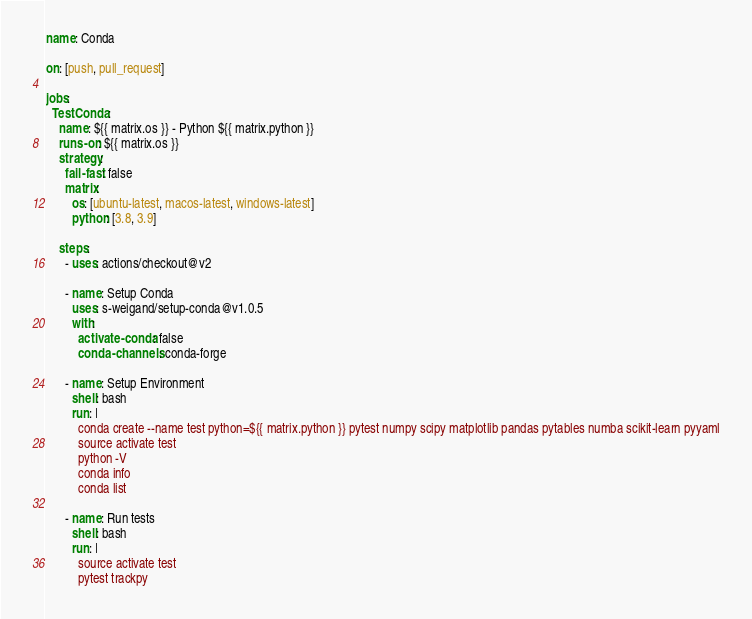Convert code to text. <code><loc_0><loc_0><loc_500><loc_500><_YAML_>name: Conda

on: [push, pull_request]

jobs:
  TestConda:
    name: ${{ matrix.os }} - Python ${{ matrix.python }}
    runs-on: ${{ matrix.os }}
    strategy:
      fail-fast: false
      matrix:
        os: [ubuntu-latest, macos-latest, windows-latest]
        python: [3.8, 3.9]

    steps:
      - uses: actions/checkout@v2

      - name: Setup Conda
        uses: s-weigand/setup-conda@v1.0.5
        with:
          activate-conda: false
          conda-channels: conda-forge

      - name: Setup Environment
        shell: bash
        run: |
          conda create --name test python=${{ matrix.python }} pytest numpy scipy matplotlib pandas pytables numba scikit-learn pyyaml
          source activate test
          python -V
          conda info
          conda list

      - name: Run tests
        shell: bash
        run: |
          source activate test
          pytest trackpy
</code> 